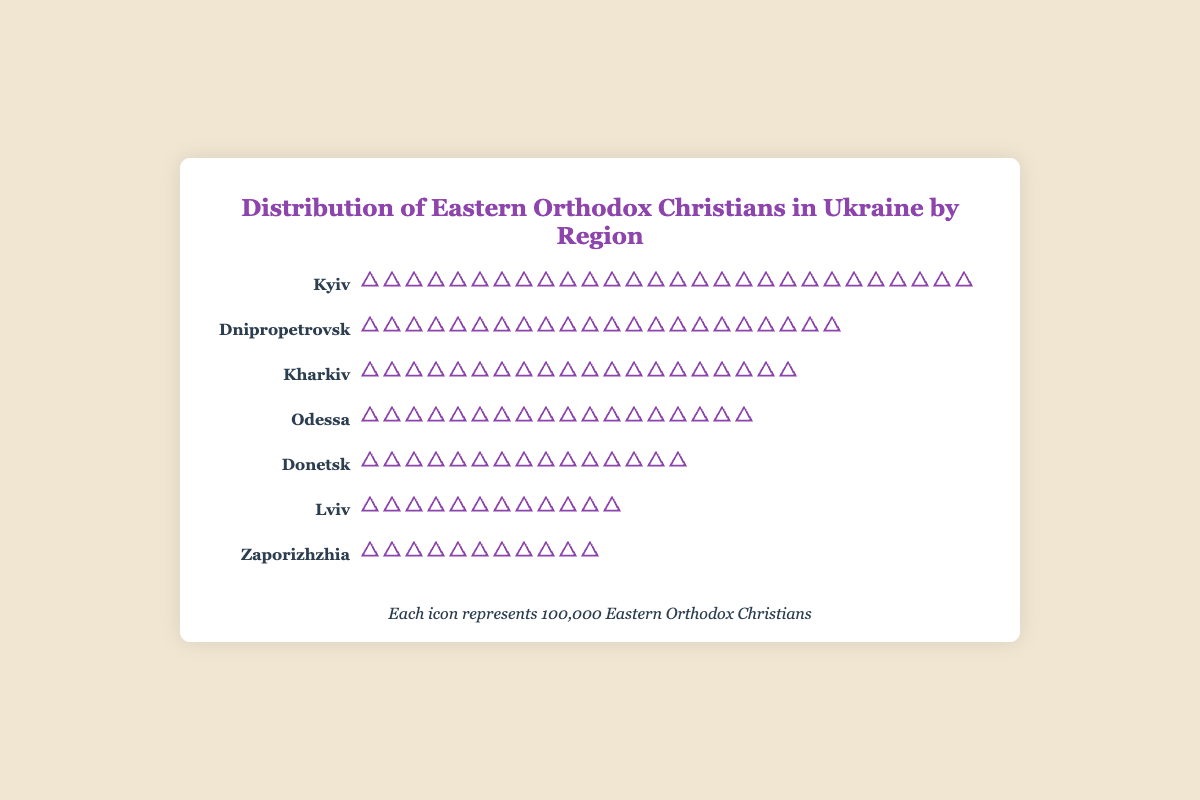What is the title of the figure? The title is located at the top-center of the figure and reads "Distribution of Eastern Orthodox Christians in Ukraine by Region".
Answer: Distribution of Eastern Orthodox Christians in Ukraine by Region Which region has the highest number of Eastern Orthodox Christians? By visually counting the icons, we can see that Kyiv has the most icons, representing 28 units of 100,000 people.
Answer: Kyiv How many regions have more than 15 icons? We need to count the regions whose icons exceed 15. Kyiv, Dnipropetrovsk, Kharkiv, and Odessa each exceed this amount.
Answer: 4 regions What is the total number of Eastern Orthodox Christians in Lviv and Zaporizhzhia combined? First, count the icons for each region: Lviv has 12 and Zaporizhzhia has 11. Summing them up, 12 + 11 = 23.
Answer: 23 units of 100,000 people How many more Eastern Orthodox Christians are there in Kyiv compared to Donetsk? Count the icons for Kyiv (28) and Donetsk (15). The difference is 28 - 15 = 13.
Answer: 13 units of 100,000 people Which region has the fewest Eastern Orthodox Christians and how many are there? By counting icons, we find that Zaporizhzhia has the fewest, with 11 icons.
Answer: Zaporizhzhia, 11 units How many more regions have Eastern Orthodox Christians between 10 and 20 units compared to those between 20 and 30 units? Regions with 10-20 units: Lviv, Odessa, Donetsk, Zaporizhzhia (4 regions), and regions with 20-30 units: Kyiv, Dnipropetrovsk, Kharkiv (3 regions). 4 - 3 = 1.
Answer: 1 more region Across all listed regions, what is the average number of Eastern Orthodox Christians? Total the values: 28 (Kyiv) + 12 (Lviv) + 22 (Dnipropetrovsk) + 18 (Odessa) + 20 (Kharkiv) + 15 (Donetsk) + 11 (Zaporizhzhia) = 126. There are 7 regions, so 126 ÷ 7 = 18.
Answer: 18 units of 100,000 people 